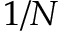Convert formula to latex. <formula><loc_0><loc_0><loc_500><loc_500>1 / N</formula> 